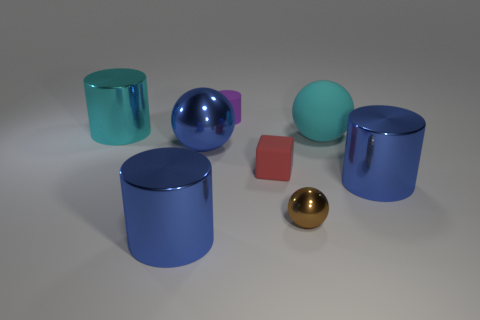Which object stands out the most due to its color? The object that stands out most prominently because of its color is the bright blue sphere. Its vibrant hue draws the eye against the subtler colors of the other objects in the scene. Is there any significance to that object's color in relation to the others? Color can play an important role in visual composition, often used to create contrast or focus. In this instance, the bright blue sphere may be a focal point in the image, perhaps intended to demonstrate contrast in both color and form among the surrounding objects. 